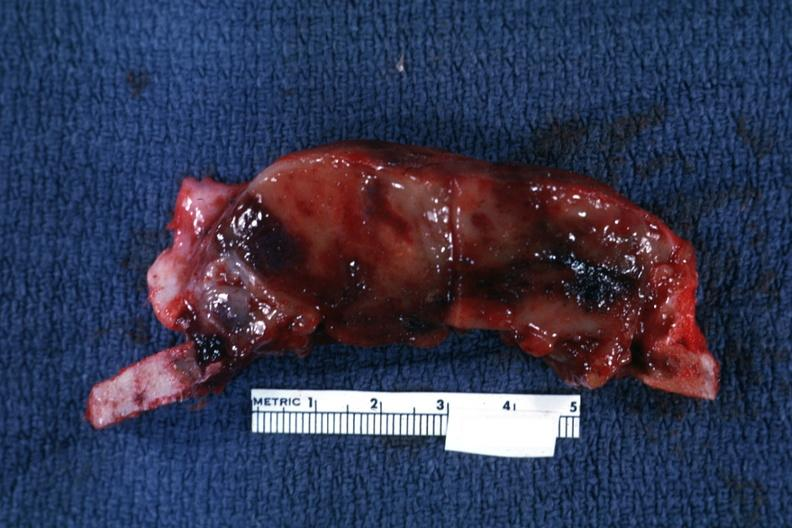does this image show section of calvarium?
Answer the question using a single word or phrase. Yes 